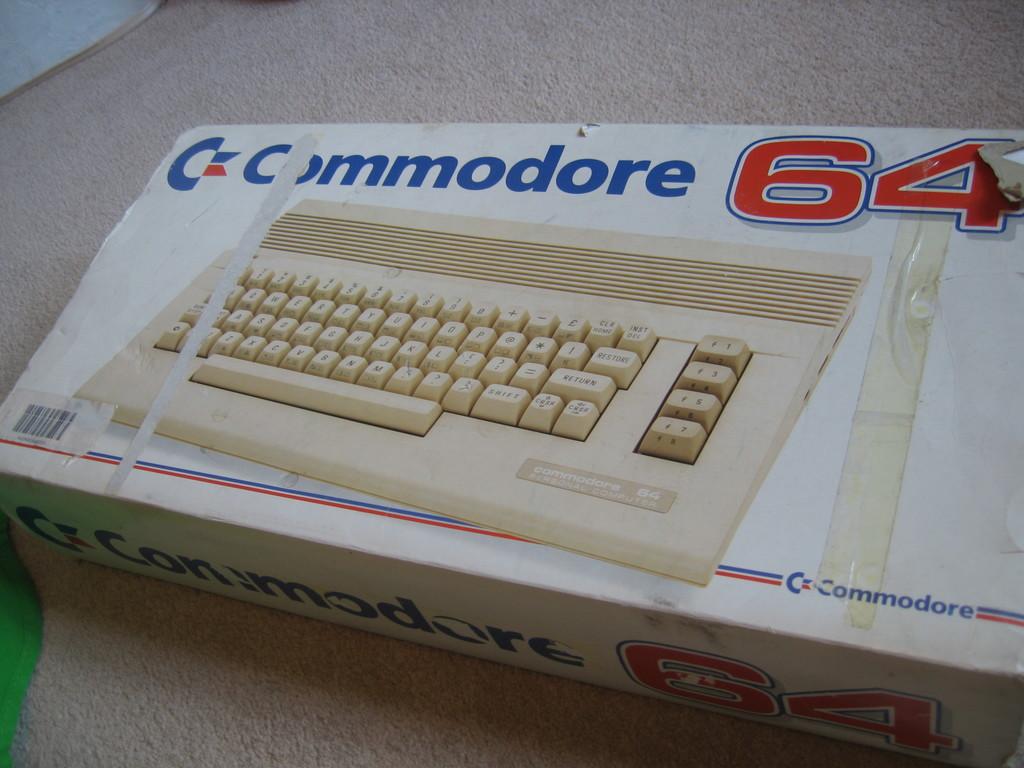What computer is this?
Keep it short and to the point. Commodore 64. 